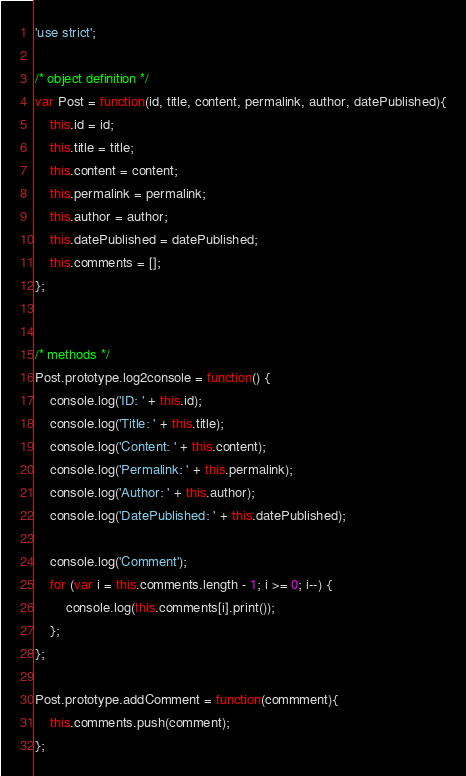<code> <loc_0><loc_0><loc_500><loc_500><_JavaScript_>'use strict';

/* object definition */
var Post = function(id, title, content, permalink, author, datePublished){
	this.id = id;
	this.title = title;
	this.content = content;
	this.permalink = permalink;
	this.author = author;
	this.datePublished = datePublished;
	this.comments = [];
};


/* methods */
Post.prototype.log2console = function() {
	console.log('ID: ' + this.id);
	console.log('Title: ' + this.title);
	console.log('Content: ' + this.content);
	console.log('Permalink: ' + this.permalink);
	console.log('Author: ' + this.author);
	console.log('DatePublished: ' + this.datePublished);

	console.log('Comment');
	for (var i = this.comments.length - 1; i >= 0; i--) {
		console.log(this.comments[i].print());
	};
};

Post.prototype.addComment = function(commment){
	this.comments.push(comment);
};


</code> 